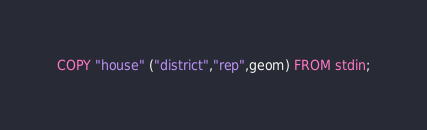Convert code to text. <code><loc_0><loc_0><loc_500><loc_500><_SQL_>COPY "house" ("district","rep",geom) FROM stdin;</code> 